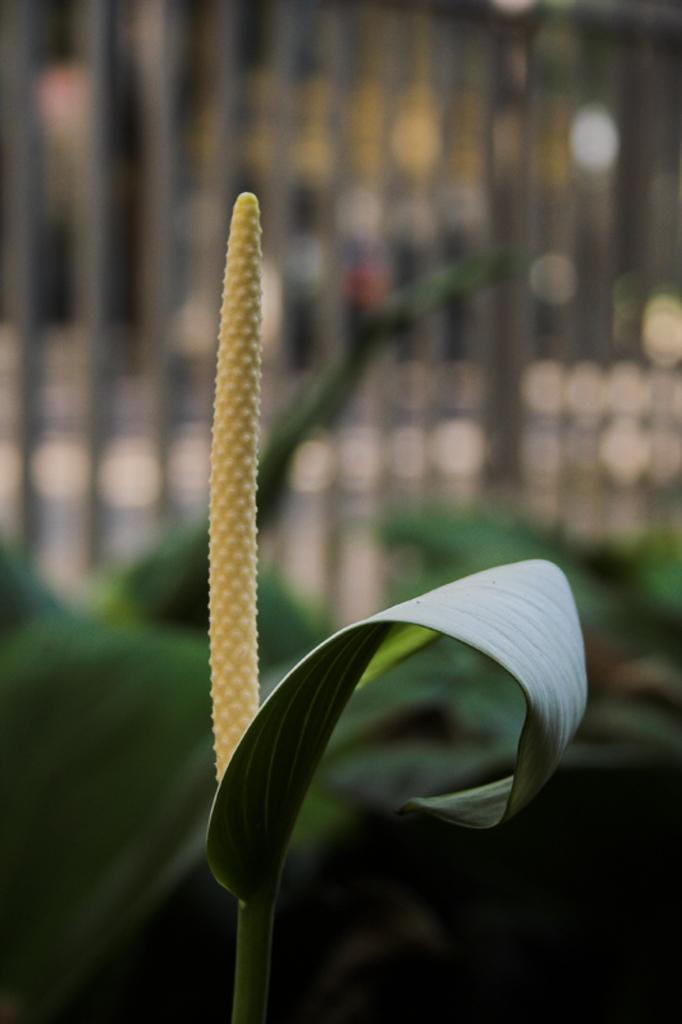What is present in the image? There is a plant in the image. Can you describe the colors of the plant? The plant has yellow and green colors. What can be observed about the background of the image? The background of the image is blurred. What season is depicted in the image? The provided facts do not mention any season, so it cannot be determined from the image. 